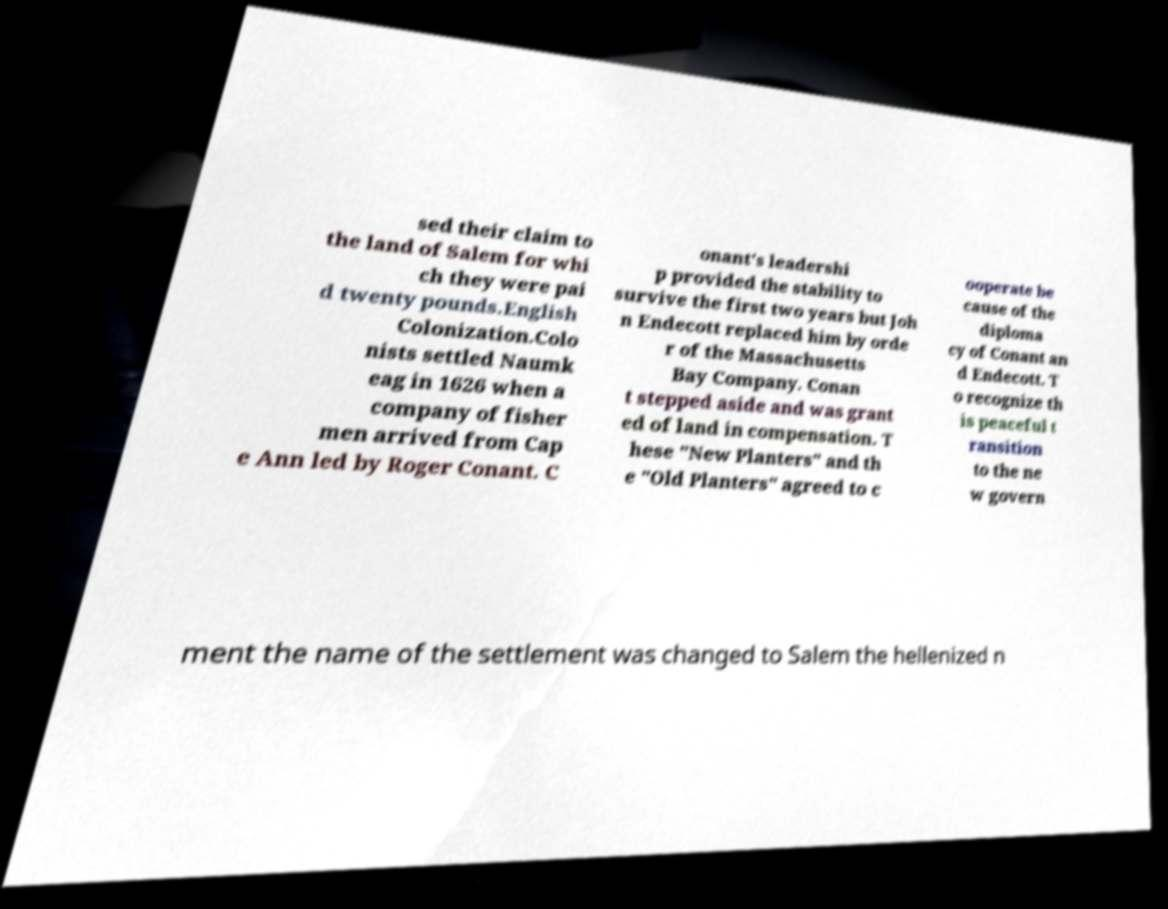Could you assist in decoding the text presented in this image and type it out clearly? sed their claim to the land of Salem for whi ch they were pai d twenty pounds.English Colonization.Colo nists settled Naumk eag in 1626 when a company of fisher men arrived from Cap e Ann led by Roger Conant. C onant's leadershi p provided the stability to survive the first two years but Joh n Endecott replaced him by orde r of the Massachusetts Bay Company. Conan t stepped aside and was grant ed of land in compensation. T hese "New Planters" and th e "Old Planters" agreed to c ooperate be cause of the diploma cy of Conant an d Endecott. T o recognize th is peaceful t ransition to the ne w govern ment the name of the settlement was changed to Salem the hellenized n 